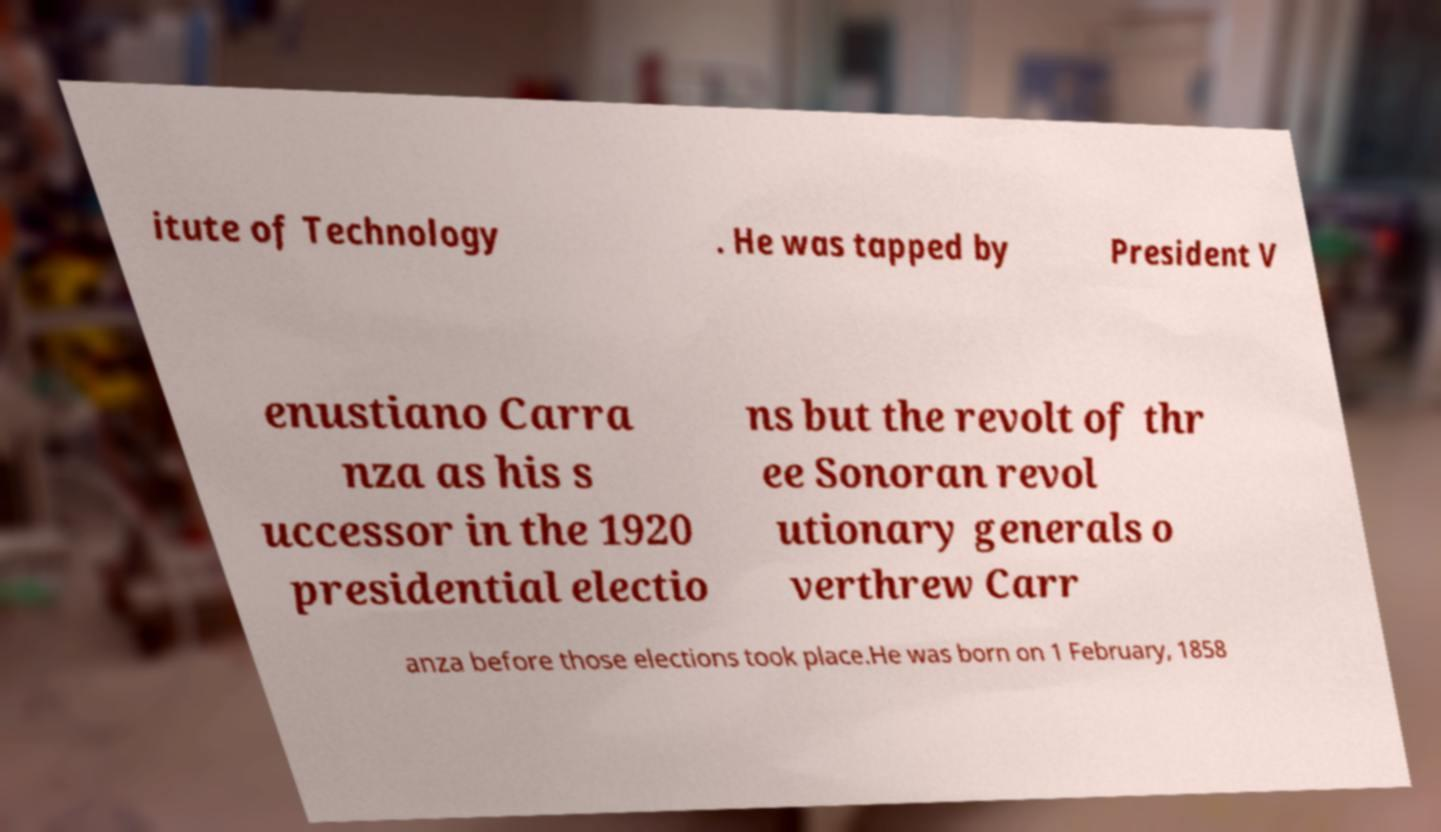Please read and relay the text visible in this image. What does it say? itute of Technology . He was tapped by President V enustiano Carra nza as his s uccessor in the 1920 presidential electio ns but the revolt of thr ee Sonoran revol utionary generals o verthrew Carr anza before those elections took place.He was born on 1 February, 1858 